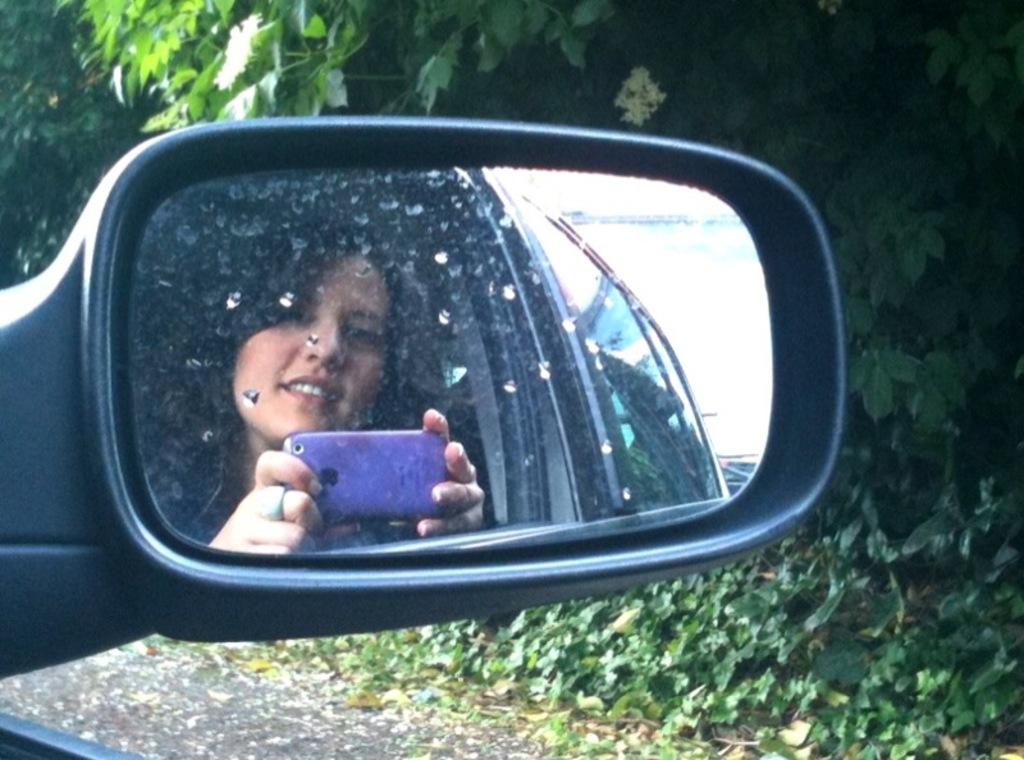Who is present in the image? There is a woman in the image. What is the woman doing in the image? The woman is using a mobile phone and taking a picture of herself. What object is present in the image that is typically found in a car? The rear mirror of a car is present in the image. What type of balloon can be seen supporting the woman in the image? There is no balloon present in the image, and the woman is not being supported by any object. 